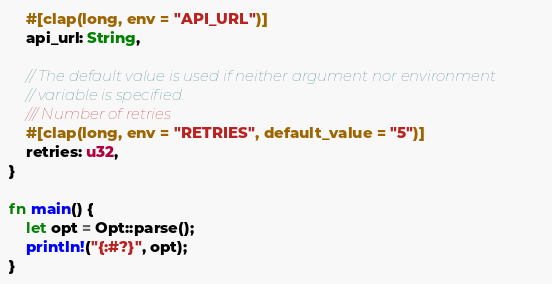<code> <loc_0><loc_0><loc_500><loc_500><_Rust_>    #[clap(long, env = "API_URL")]
    api_url: String,

    // The default value is used if neither argument nor environment
    // variable is specified.
    /// Number of retries
    #[clap(long, env = "RETRIES", default_value = "5")]
    retries: u32,
}

fn main() {
    let opt = Opt::parse();
    println!("{:#?}", opt);
}
</code> 